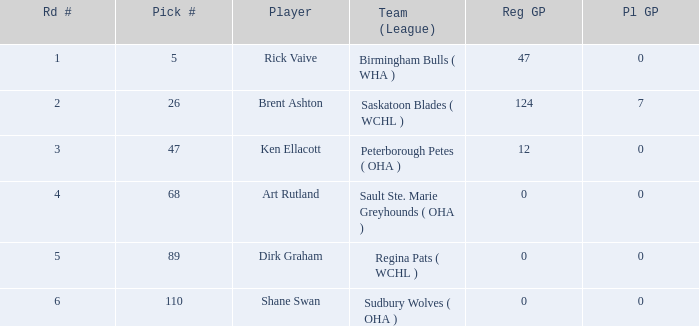How many stages exist for options less than 5? 0.0. Can you parse all the data within this table? {'header': ['Rd #', 'Pick #', 'Player', 'Team (League)', 'Reg GP', 'Pl GP'], 'rows': [['1', '5', 'Rick Vaive', 'Birmingham Bulls ( WHA )', '47', '0'], ['2', '26', 'Brent Ashton', 'Saskatoon Blades ( WCHL )', '124', '7'], ['3', '47', 'Ken Ellacott', 'Peterborough Petes ( OHA )', '12', '0'], ['4', '68', 'Art Rutland', 'Sault Ste. Marie Greyhounds ( OHA )', '0', '0'], ['5', '89', 'Dirk Graham', 'Regina Pats ( WCHL )', '0', '0'], ['6', '110', 'Shane Swan', 'Sudbury Wolves ( OHA )', '0', '0']]} 